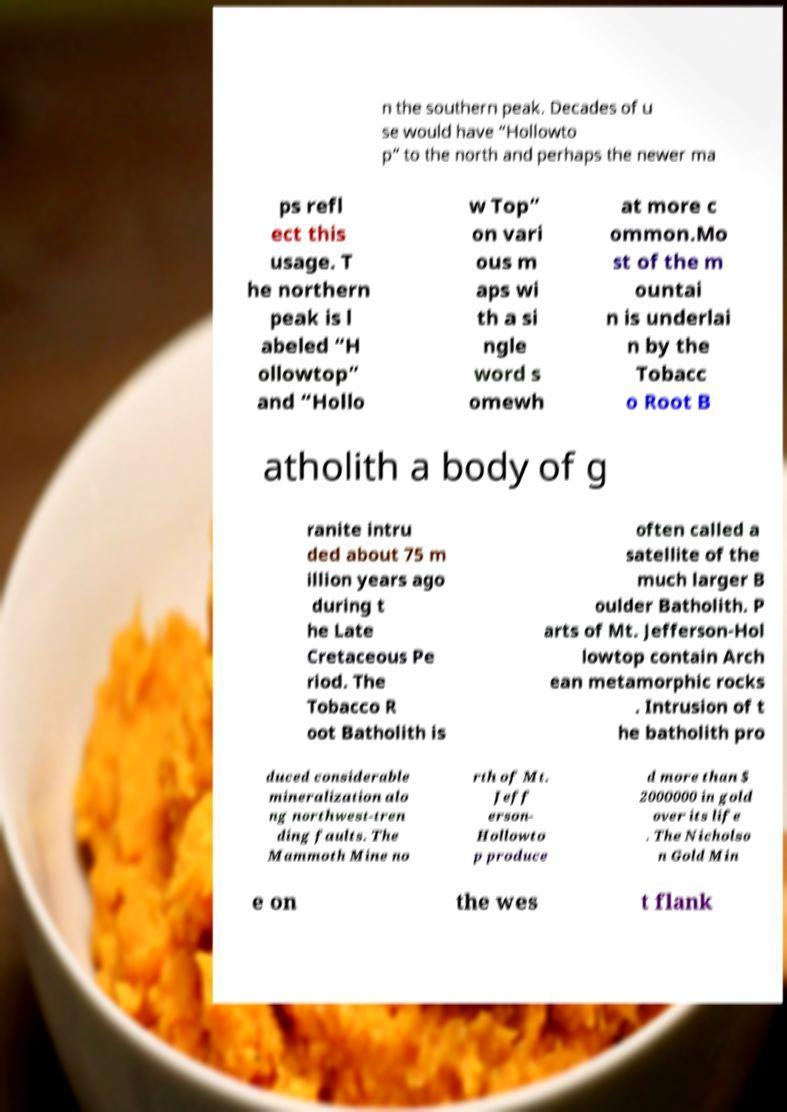What messages or text are displayed in this image? I need them in a readable, typed format. n the southern peak. Decades of u se would have “Hollowto p” to the north and perhaps the newer ma ps refl ect this usage. T he northern peak is l abeled “H ollowtop” and “Hollo w Top” on vari ous m aps wi th a si ngle word s omewh at more c ommon.Mo st of the m ountai n is underlai n by the Tobacc o Root B atholith a body of g ranite intru ded about 75 m illion years ago during t he Late Cretaceous Pe riod. The Tobacco R oot Batholith is often called a satellite of the much larger B oulder Batholith. P arts of Mt. Jefferson-Hol lowtop contain Arch ean metamorphic rocks . Intrusion of t he batholith pro duced considerable mineralization alo ng northwest-tren ding faults. The Mammoth Mine no rth of Mt. Jeff erson- Hollowto p produce d more than $ 2000000 in gold over its life . The Nicholso n Gold Min e on the wes t flank 